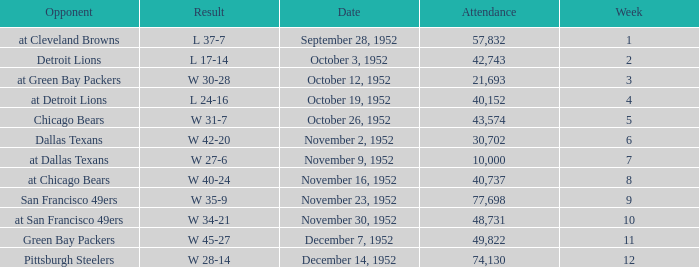When is the last week that has a result of a w 34-21? 10.0. 